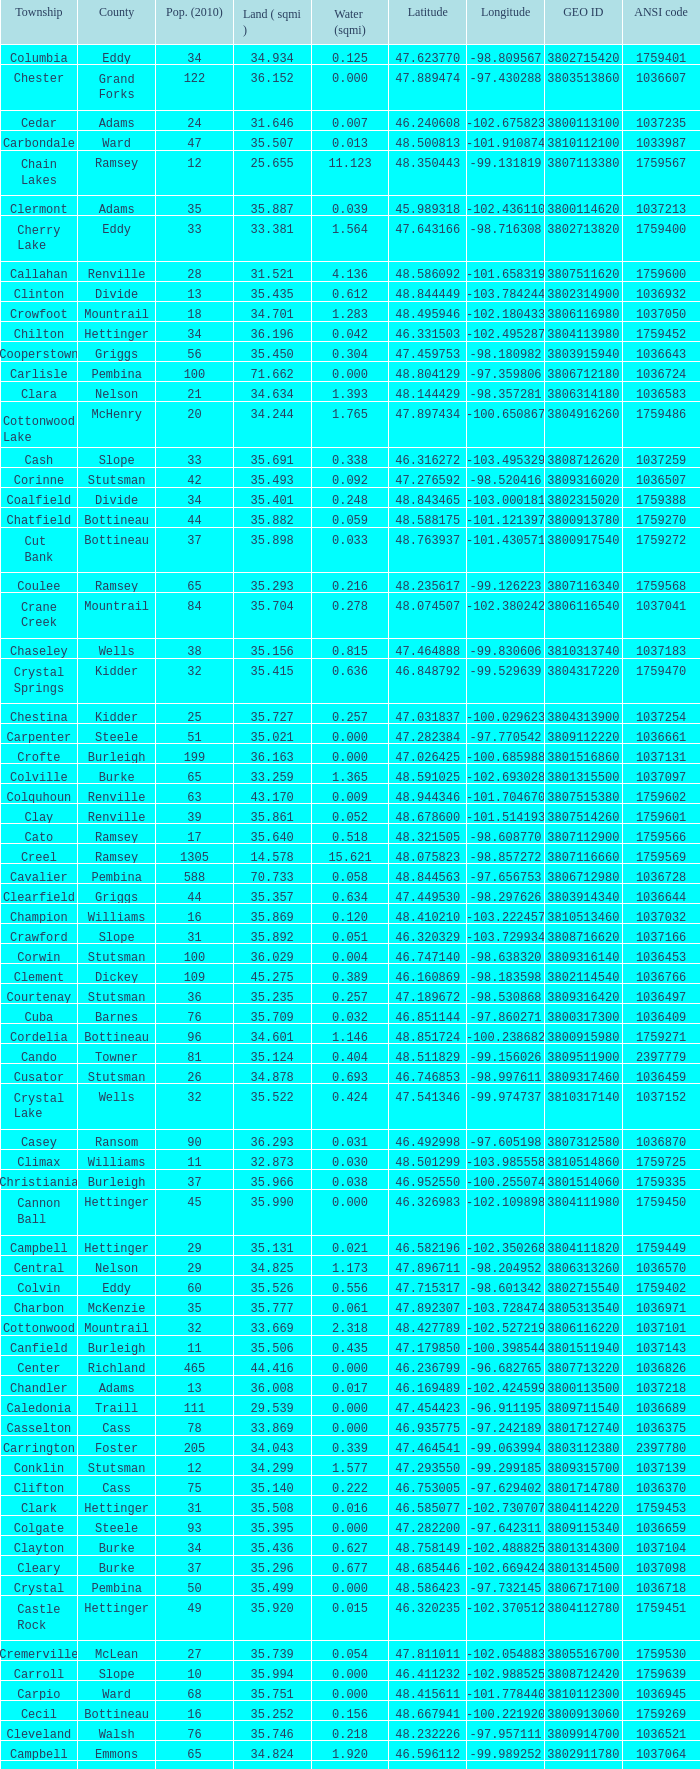What was the land area in sqmi that has a latitude of 48.763937? 35.898. 